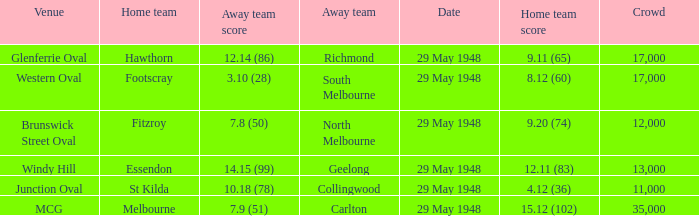During melbourne's home game, who was the away team? Carlton. 